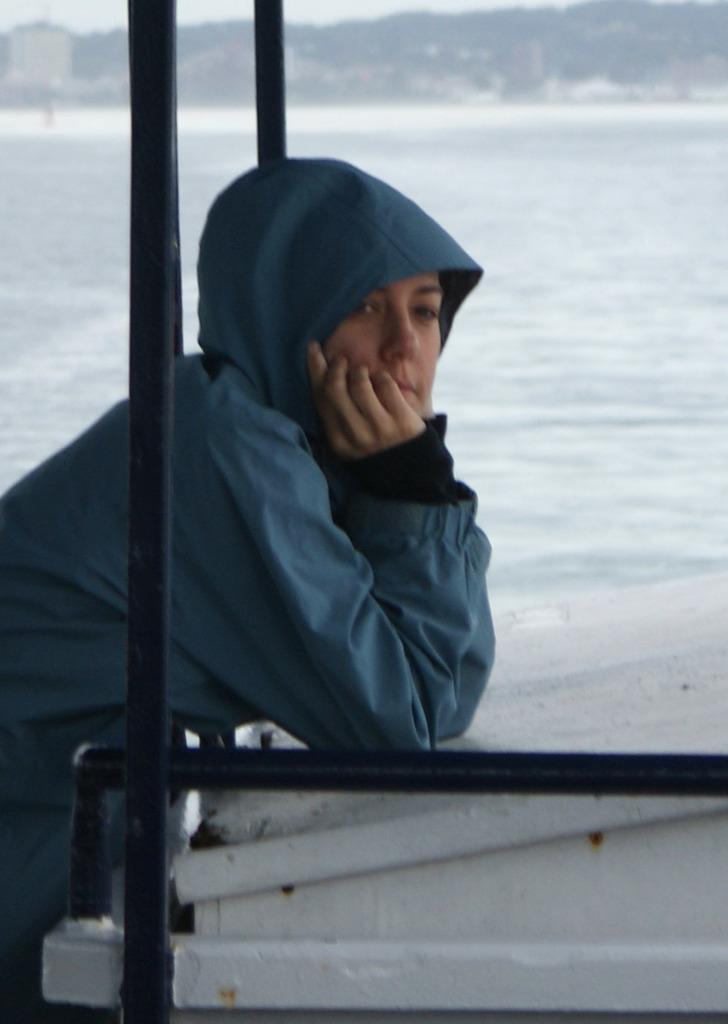Can you describe this image briefly? In the center of the image there is a person standing at the wall. In the background there is a water, hill and sky. 